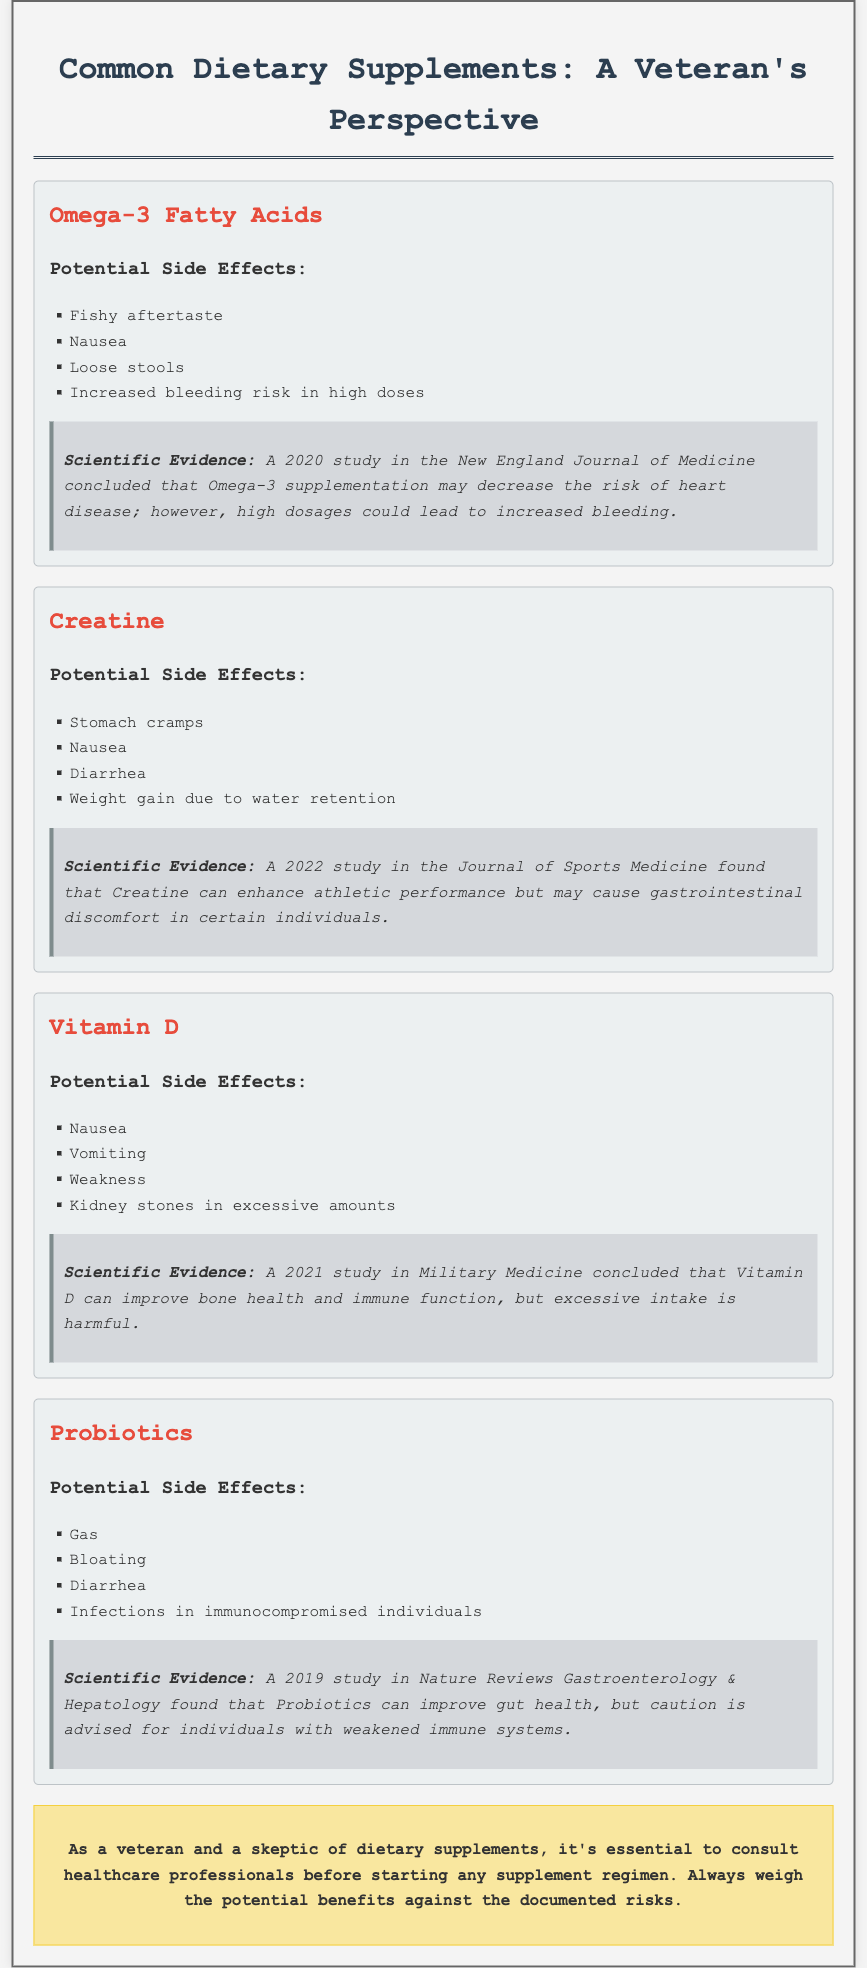what are the potential side effects of Omega-3 fatty acids? The document lists the specific side effects associated with Omega-3 fatty acids, including fishy aftertaste, nausea, loose stools, and increased bleeding risk in high doses.
Answer: fishy aftertaste, nausea, loose stools, increased bleeding risk what year was the study on Vitamin D published? The scientific evidence section for Vitamin D references a study published in 2021 as per the details provided.
Answer: 2021 which supplement is noted for causing weight gain due to water retention? The potential side effects of Creatine highlight weight gain due to water retention as one of its effects.
Answer: Creatine what is the main benefit of Probiotics according to the document? The document states that Probiotics can improve gut health, which is mentioned in the scientific evidence.
Answer: improve gut health which study concluded that Omega-3 supplementation may decrease the risk of heart disease? The document cites a 2020 study in the New England Journal of Medicine as the source that concludes Omega-3 supplementation may decrease heart disease risk.
Answer: 2020 study in the New England Journal of Medicine what precaution is advised for individuals taking Probiotics? The document specifies that caution is advised for individuals with weakened immune systems when taking Probiotics.
Answer: caution for individuals with weakened immune systems what kind of document is this note classified as? The note serves as a fact sheet summarizing common dietary supplements, outlining their benefits, side effects, and scientific evidence regarding their use.
Answer: fact sheet 